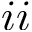Convert formula to latex. <formula><loc_0><loc_0><loc_500><loc_500>i i</formula> 